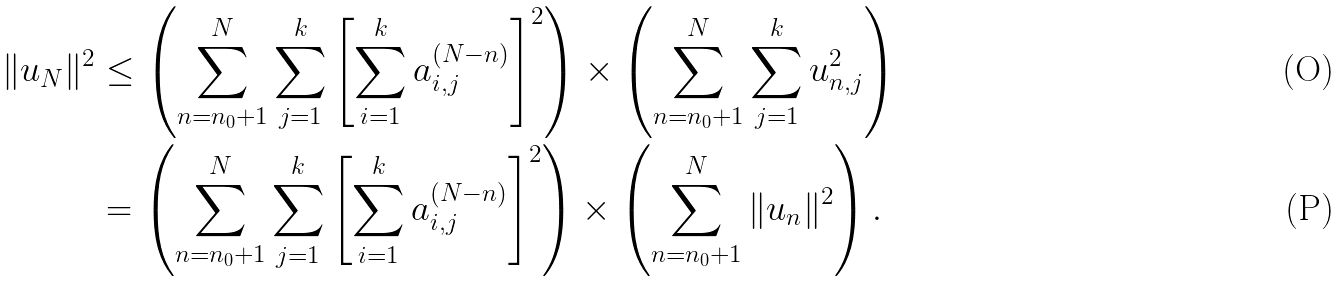<formula> <loc_0><loc_0><loc_500><loc_500>\| { u } _ { N } \| ^ { 2 } & \leq \left ( \sum _ { n = n _ { 0 } + 1 } ^ { N } \sum _ { j = 1 } ^ { k } \left [ \sum _ { i = 1 } ^ { k } a _ { i , j } ^ { ( N - n ) } \right ] ^ { 2 } \right ) \times \left ( \sum _ { n = n _ { 0 } + 1 } ^ { N } \sum _ { j = 1 } ^ { k } u _ { n , j } ^ { 2 } \right ) \\ & = \left ( \sum _ { n = n _ { 0 } + 1 } ^ { N } \sum _ { j = 1 } ^ { k } \left [ \sum _ { i = 1 } ^ { k } a _ { i , j } ^ { ( N - n ) } \right ] ^ { 2 } \right ) \times \left ( \sum _ { n = n _ { 0 } + 1 } ^ { N } \| { u } _ { n } \| ^ { 2 } \right ) .</formula> 